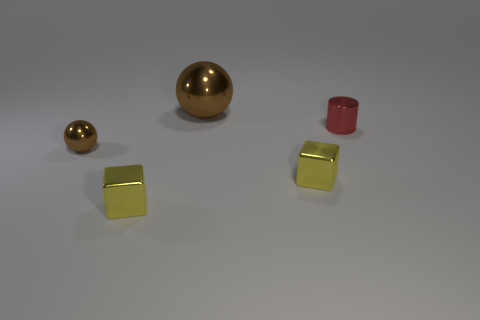Add 1 tiny blocks. How many objects exist? 6 Subtract all spheres. How many objects are left? 3 Subtract all red things. Subtract all metal blocks. How many objects are left? 2 Add 1 yellow objects. How many yellow objects are left? 3 Add 1 tiny red shiny cylinders. How many tiny red shiny cylinders exist? 2 Subtract 0 brown cylinders. How many objects are left? 5 